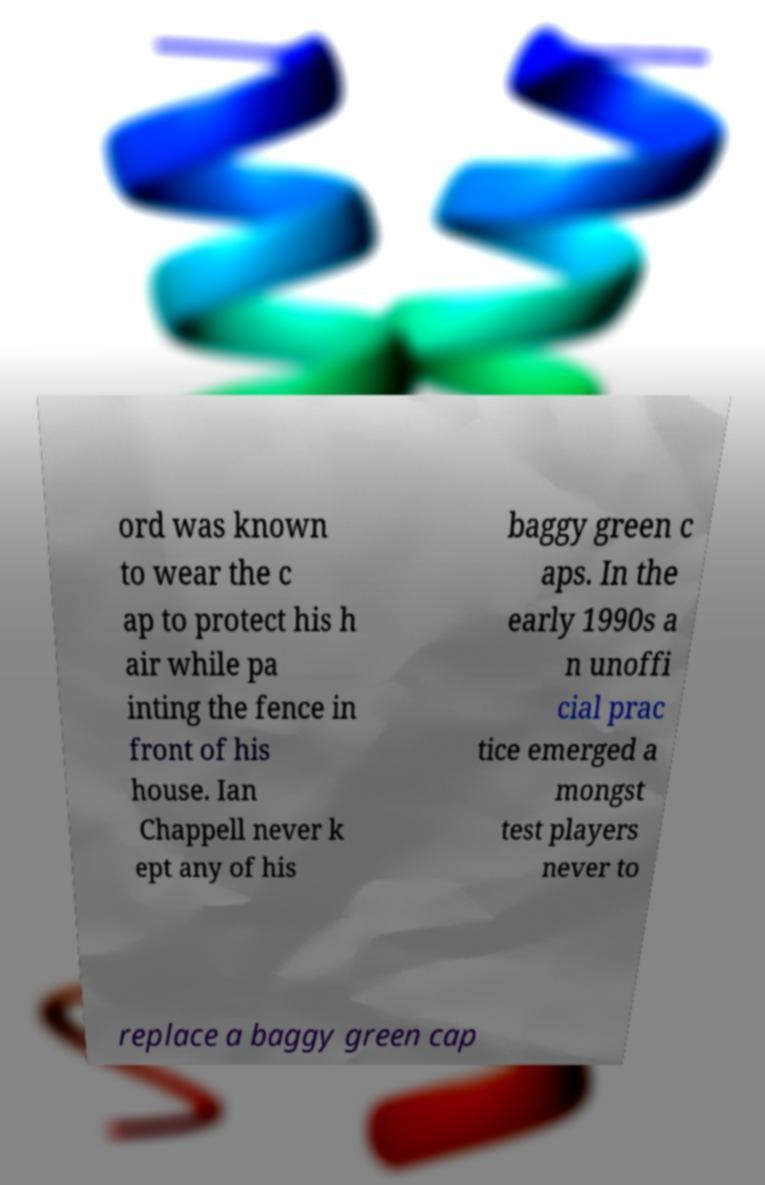Can you read and provide the text displayed in the image?This photo seems to have some interesting text. Can you extract and type it out for me? ord was known to wear the c ap to protect his h air while pa inting the fence in front of his house. Ian Chappell never k ept any of his baggy green c aps. In the early 1990s a n unoffi cial prac tice emerged a mongst test players never to replace a baggy green cap 